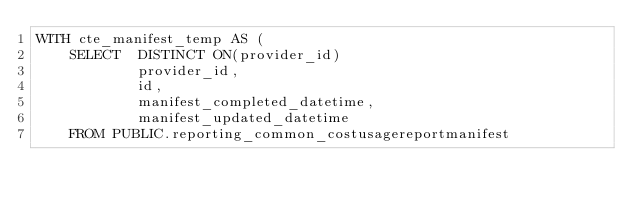<code> <loc_0><loc_0><loc_500><loc_500><_SQL_>WITH cte_manifest_temp AS (
    SELECT  DISTINCT ON(provider_id)
            provider_id,
            id,
            manifest_completed_datetime,
            manifest_updated_datetime
    FROM PUBLIC.reporting_common_costusagereportmanifest</code> 